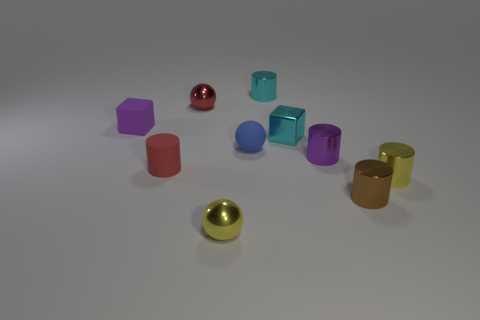Do the purple thing that is right of the rubber cylinder and the purple rubber thing have the same size?
Make the answer very short. Yes. What color is the cylinder that is behind the red cylinder and in front of the cyan metal cylinder?
Provide a short and direct response. Purple. How many objects are either big red blocks or small metal cylinders that are in front of the red shiny ball?
Your response must be concise. 3. What material is the tiny cylinder on the left side of the tiny metallic sphere behind the block on the left side of the small red matte cylinder made of?
Give a very brief answer. Rubber. Are there any other things that have the same material as the red cylinder?
Make the answer very short. Yes. Is the color of the ball that is in front of the tiny brown thing the same as the small rubber ball?
Your response must be concise. No. What number of gray objects are tiny metallic cylinders or tiny cylinders?
Your answer should be compact. 0. Are there the same number of small blue cylinders and red objects?
Make the answer very short. No. What number of other things are the same shape as the tiny brown thing?
Give a very brief answer. 4. Are the cyan cylinder and the red cylinder made of the same material?
Give a very brief answer. No. 